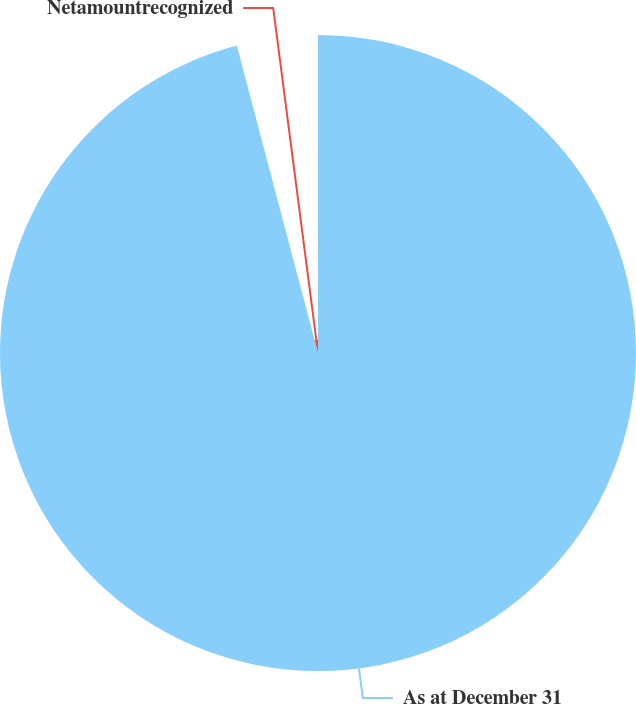<chart> <loc_0><loc_0><loc_500><loc_500><pie_chart><fcel>As at December 31<fcel>Netamountrecognized<nl><fcel>95.89%<fcel>4.11%<nl></chart> 